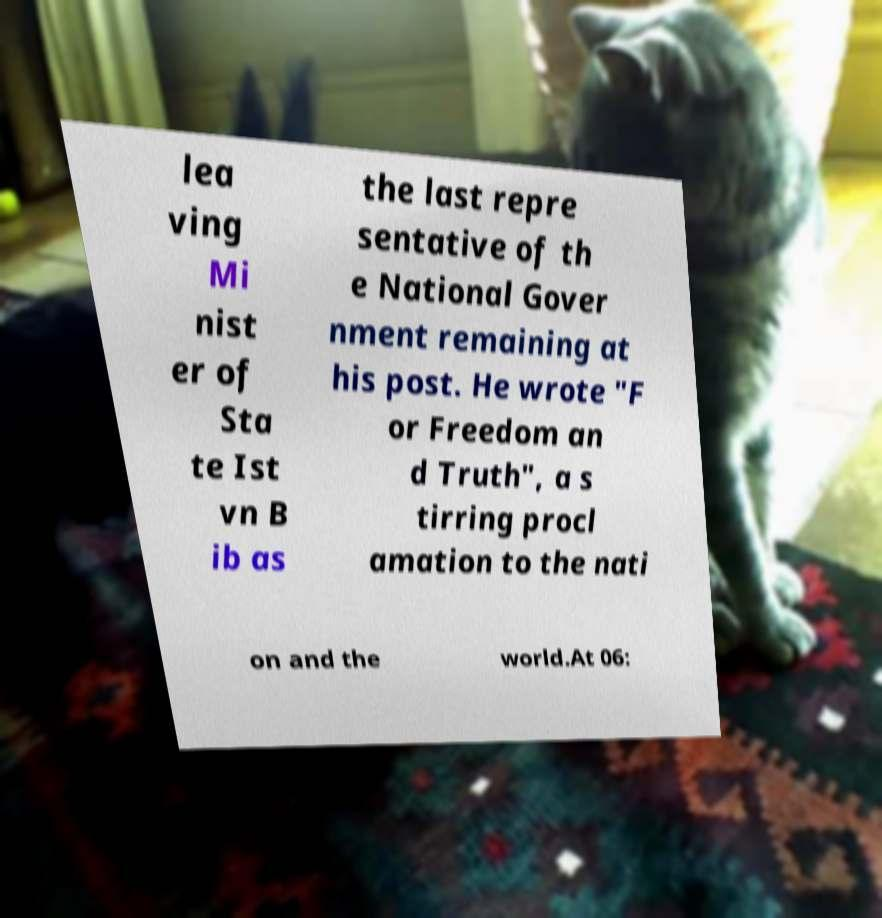Could you assist in decoding the text presented in this image and type it out clearly? lea ving Mi nist er of Sta te Ist vn B ib as the last repre sentative of th e National Gover nment remaining at his post. He wrote "F or Freedom an d Truth", a s tirring procl amation to the nati on and the world.At 06: 